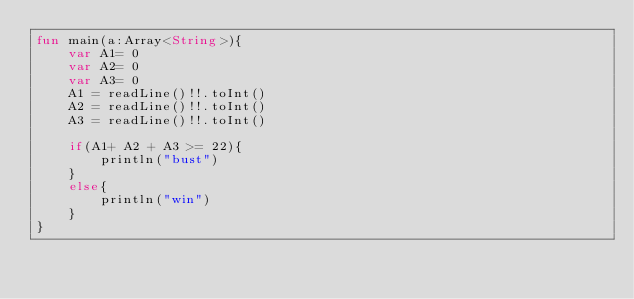Convert code to text. <code><loc_0><loc_0><loc_500><loc_500><_Kotlin_>fun main(a:Array<String>){
    var A1= 0
    var A2= 0
    var A3= 0
    A1 = readLine()!!.toInt()
    A2 = readLine()!!.toInt()
    A3 = readLine()!!.toInt()

    if(A1+ A2 + A3 >= 22){
        println("bust")
    }
    else{
        println("win")
    }
}</code> 